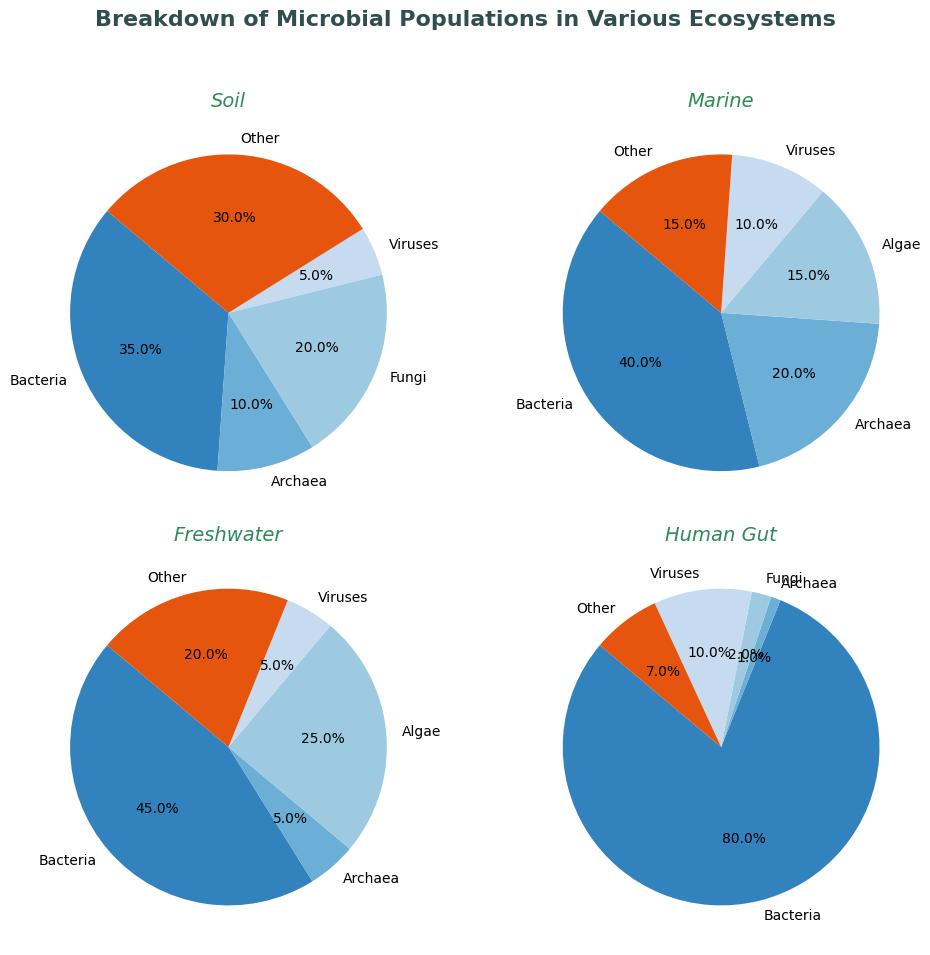What is the most abundant microbial group in the Human Gut ecosystem? In the Human Gut pie chart, the largest section represents Bacteria with 80%. This is visually noticeable as it occupies the largest portion of the pie.
Answer: Bacteria (80%) Which microbial group has the smallest percentage in the Soil ecosystem? In the Soil pie chart, Archaea occupies the smallest segment visibly compared to others, with a percentage of 10%.
Answer: Archaea (10%) How do the percentages of Archaea in Marine and Freshwater ecosystems compare? The Marine pie chart shows Archaea at 20%, and the Freshwater pie chart shows Archaea at 5%. Comparing these, Archaea has a higher percentage in Marine ecosystems by 15%.
Answer: Marine (20%) > Freshwater (5%) What is the combined percentage of Viruses in all four ecosystems? Reviewing all pie charts: Soil (5%), Marine (10%), Freshwater (5%), Human Gut (10%). Adding these together results in 5 + 10 + 5 + 10 = 30%.
Answer: 30% Which ecosystem has the highest percentage of 'Other' microorganisms? The Soil pie chart shows 'Other' with 30%, Marine with 15%, Freshwater with 20%, and Human Gut with 7%. 'Other' microorganisms are highest in the Soil ecosystem.
Answer: Soil (30%) Compare the percentage of Bacteria in Soil and Freshwater ecosystems. The pie chart for Soil shows Bacteria at 35%, while Freshwater shows Bacteria at 45%. Thus, Freshwater has a higher percentage of Bacteria by 10%.
Answer: Freshwater (45%) > Soil (35%) What is the second most abundant microbial group in the Marine ecosystem? In the Marine pie chart, the largest segment is Bacteria (40%), followed by Archaea (20%). Thus, Archaea is the second most abundant microbial group in the Marine ecosystem.
Answer: Archaea (20%) What percentage of the human gut microbiota is not Bacteria? The pie chart for the Human Gut shows Bacteria at 80%. Hence, the remaining percentage (Fungi, Viruses, Archaea, and Other) adds up to 100 - 80 = 20%.
Answer: 20% How does the presence of Fungi in Soil compare to that in the Human Gut? In the Soil pie chart, Fungi is 20%, while in the Human Gut pie chart, it is 2%. Conclusively, Fungi is more prevalent in the Soil ecosystem by 18%.
Answer: Soil (20%) > Human Gut (2%) What is the sum of Algae percentages in Marine and Freshwater ecosystems? In the Marine pie chart, Algae accounts for 15%, and in Freshwater, it accounts for 25%. Adding these together gives 15 + 25 = 40%.
Answer: 40% 